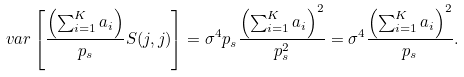<formula> <loc_0><loc_0><loc_500><loc_500>v a r \left [ \frac { \left ( \sum ^ { K } _ { i = 1 } a _ { i } \right ) } { p _ { s } } S ( j , j ) \right ] & = \sigma ^ { 4 } p _ { s } \frac { \left ( \sum ^ { K } _ { i = 1 } a _ { i } \right ) ^ { 2 } } { p _ { s } ^ { 2 } } = \sigma ^ { 4 } \frac { \left ( \sum ^ { K } _ { i = 1 } a _ { i } \right ) ^ { 2 } } { p _ { s } } .</formula> 